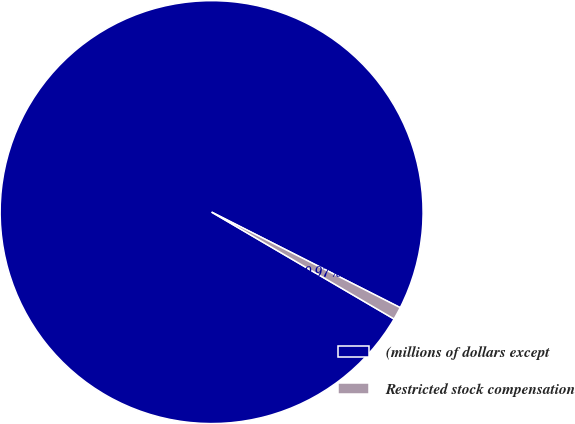<chart> <loc_0><loc_0><loc_500><loc_500><pie_chart><fcel>(millions of dollars except<fcel>Restricted stock compensation<nl><fcel>99.03%<fcel>0.97%<nl></chart> 